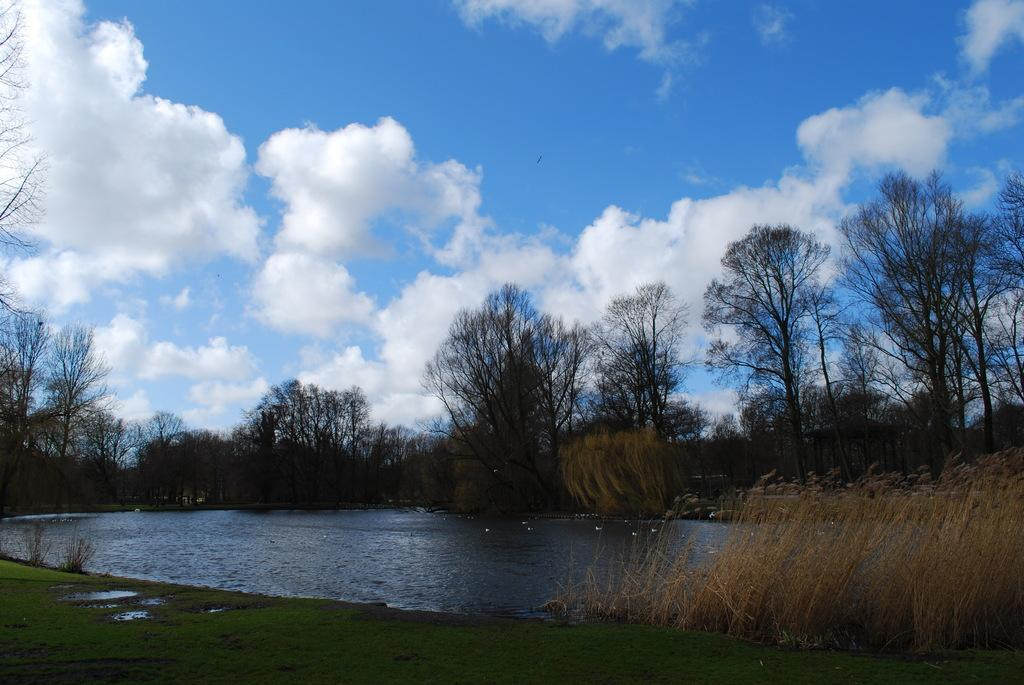What type of vegetation is at the bottom of the image? There is grass at the bottom of the image. What natural element is present in the image besides grass? There is water in the image. What can be seen in the middle of the image? There are trees in the middle of the image. What color is the sky in the image? The sky is blue in color and visible at the top of the image. What type of lumber is being used to draw on the grass in the image? There is no lumber or drawing activity present in the image. How big is the chalk used to write on the trees in the image? There is no chalk or writing activity present in the image. 